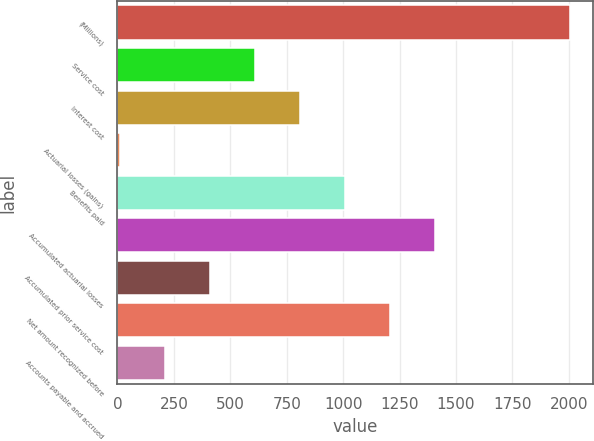Convert chart to OTSL. <chart><loc_0><loc_0><loc_500><loc_500><bar_chart><fcel>(Millions)<fcel>Service cost<fcel>Interest cost<fcel>Actuarial losses (gains)<fcel>Benefits paid<fcel>Accumulated actuarial losses<fcel>Accumulated prior service cost<fcel>Net amount recognized before<fcel>Accounts payable and accrued<nl><fcel>2006<fcel>608.8<fcel>808.4<fcel>10<fcel>1008<fcel>1407.2<fcel>409.2<fcel>1207.6<fcel>209.6<nl></chart> 